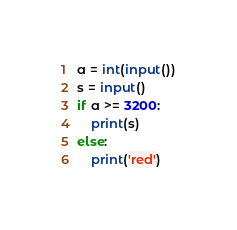<code> <loc_0><loc_0><loc_500><loc_500><_Python_>a = int(input())
s = input()
if a >= 3200:
    print(s)
else:
    print('red')</code> 